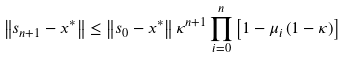<formula> <loc_0><loc_0><loc_500><loc_500>\left \| s _ { n + 1 } - x ^ { \ast } \right \| \leq \left \| s _ { 0 } - x ^ { \ast } \right \| \kappa ^ { n + 1 } \prod _ { i = 0 } ^ { n } \left [ 1 - \mu _ { i } \left ( 1 - \kappa \right ) \right ]</formula> 